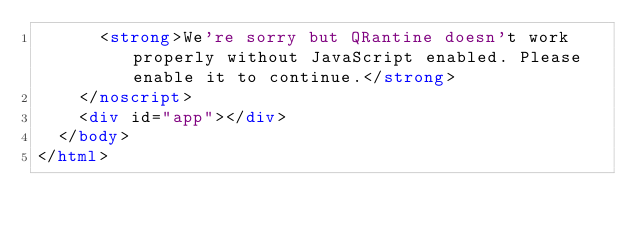Convert code to text. <code><loc_0><loc_0><loc_500><loc_500><_HTML_>      <strong>We're sorry but QRantine doesn't work properly without JavaScript enabled. Please enable it to continue.</strong>
    </noscript>
    <div id="app"></div>
  </body>
</html>
</code> 